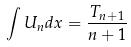Convert formula to latex. <formula><loc_0><loc_0><loc_500><loc_500>\int U _ { n } d x = \frac { T _ { n + 1 } } { n + 1 }</formula> 